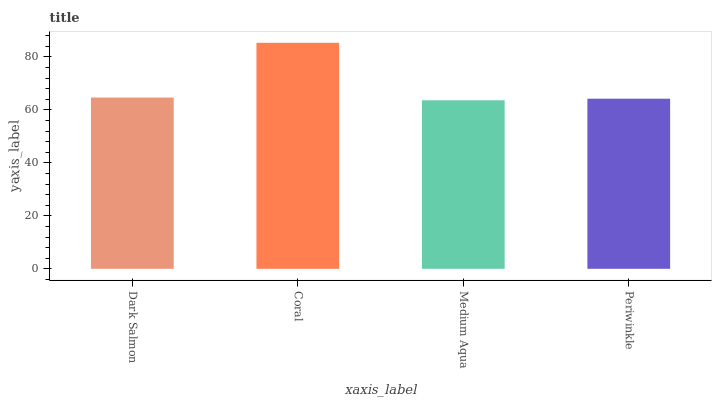Is Coral the minimum?
Answer yes or no. No. Is Medium Aqua the maximum?
Answer yes or no. No. Is Coral greater than Medium Aqua?
Answer yes or no. Yes. Is Medium Aqua less than Coral?
Answer yes or no. Yes. Is Medium Aqua greater than Coral?
Answer yes or no. No. Is Coral less than Medium Aqua?
Answer yes or no. No. Is Dark Salmon the high median?
Answer yes or no. Yes. Is Periwinkle the low median?
Answer yes or no. Yes. Is Medium Aqua the high median?
Answer yes or no. No. Is Medium Aqua the low median?
Answer yes or no. No. 